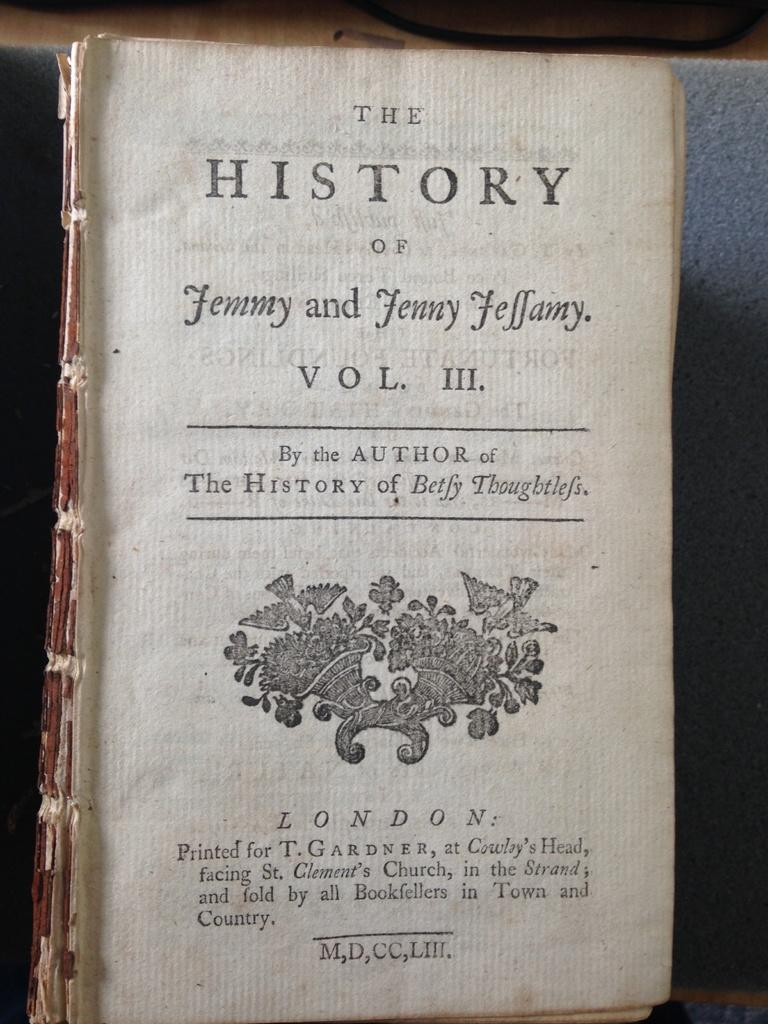Provide a one-sentence caption for the provided image. A book by the author of The History of Betfy Thoughtlefs is missing its cover. 